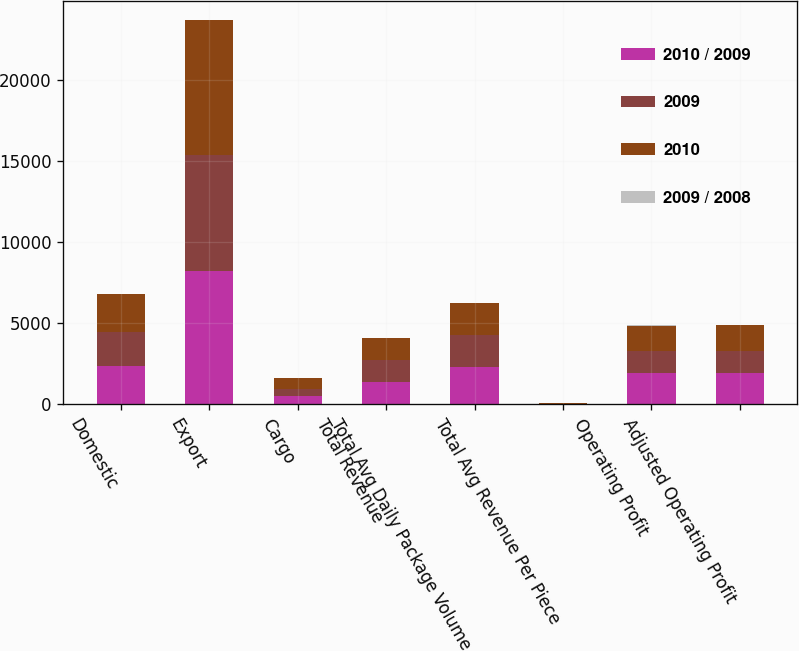Convert chart. <chart><loc_0><loc_0><loc_500><loc_500><stacked_bar_chart><ecel><fcel>Domestic<fcel>Export<fcel>Cargo<fcel>Total Revenue<fcel>Total Avg Daily Package Volume<fcel>Total Avg Revenue Per Piece<fcel>Operating Profit<fcel>Adjusted Operating Profit<nl><fcel>2010 / 2009<fcel>2365<fcel>8234<fcel>534<fcel>1367<fcel>2288<fcel>18.31<fcel>1904<fcel>1904<nl><fcel>2009<fcel>2111<fcel>7176<fcel>412<fcel>1367<fcel>2014<fcel>18.23<fcel>1367<fcel>1367<nl><fcel>2010<fcel>2344<fcel>8294<fcel>655<fcel>1367<fcel>1963<fcel>21.5<fcel>1580<fcel>1607<nl><fcel>2009 / 2008<fcel>12<fcel>14.7<fcel>29.6<fcel>14.8<fcel>13.6<fcel>0.4<fcel>39.3<fcel>39.3<nl></chart> 